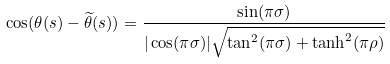Convert formula to latex. <formula><loc_0><loc_0><loc_500><loc_500>\cos ( \theta ( s ) - \widetilde { \theta } ( s ) ) = \frac { \sin ( \pi \sigma ) } { | \cos ( \pi \sigma ) | \sqrt { \tan ^ { 2 } ( \pi \sigma ) + \tanh ^ { 2 } ( \pi \rho ) } }</formula> 